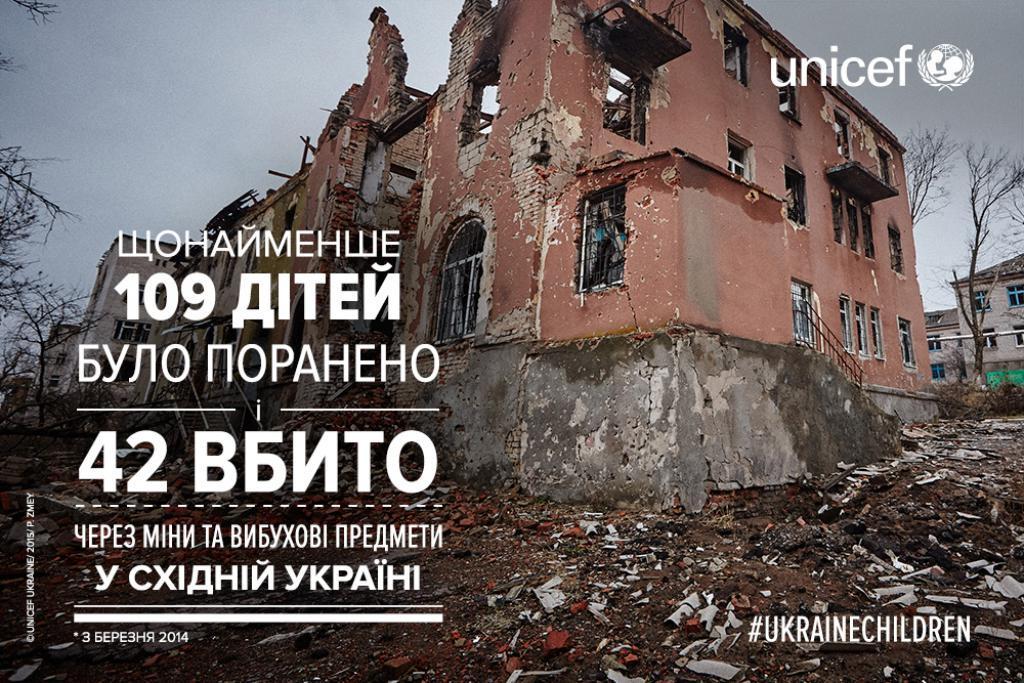Can you describe this image briefly? In this image we can see some text on the picture and there is a destructed building and there are few trees, buildings and the sky in the background. 